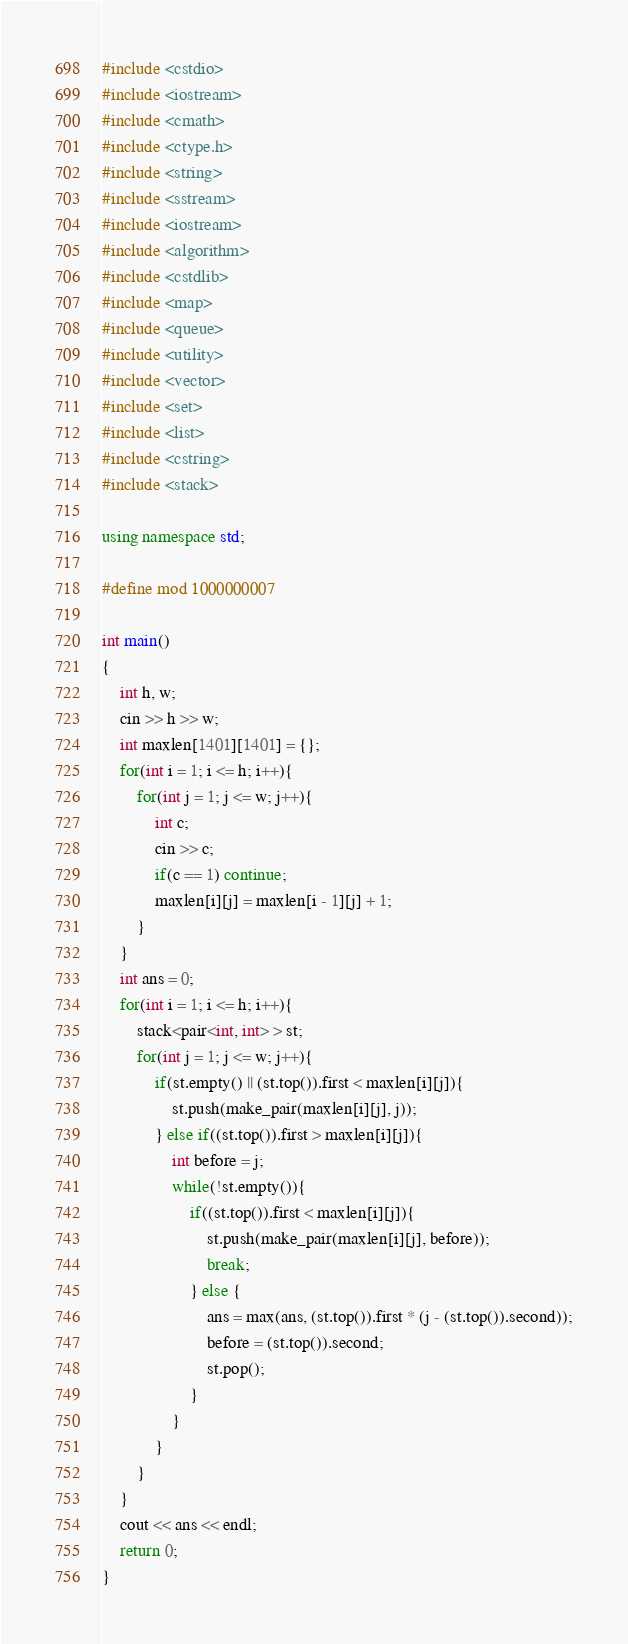Convert code to text. <code><loc_0><loc_0><loc_500><loc_500><_C++_>#include <cstdio>
#include <iostream>
#include <cmath>
#include <ctype.h>
#include <string> 
#include <sstream>
#include <iostream>
#include <algorithm>
#include <cstdlib>
#include <map>
#include <queue>
#include <utility>
#include <vector>
#include <set>
#include <list>
#include <cstring>
#include <stack>
   
using namespace std;

#define mod 1000000007

int main()
{
    int h, w;
    cin >> h >> w;
    int maxlen[1401][1401] = {};
    for(int i = 1; i <= h; i++){
        for(int j = 1; j <= w; j++){
            int c;
            cin >> c;
            if(c == 1) continue;
            maxlen[i][j] = maxlen[i - 1][j] + 1;
        }
    }
    int ans = 0;
    for(int i = 1; i <= h; i++){
        stack<pair<int, int> > st;
        for(int j = 1; j <= w; j++){
            if(st.empty() || (st.top()).first < maxlen[i][j]){
                st.push(make_pair(maxlen[i][j], j));
            } else if((st.top()).first > maxlen[i][j]){
                int before = j;
                while(!st.empty()){
                    if((st.top()).first < maxlen[i][j]){
                        st.push(make_pair(maxlen[i][j], before));
                        break;
                    } else {
                        ans = max(ans, (st.top()).first * (j - (st.top()).second));
                        before = (st.top()).second;
                        st.pop();
                    }
                }
            }
        }
    }
    cout << ans << endl;
    return 0;
}</code> 